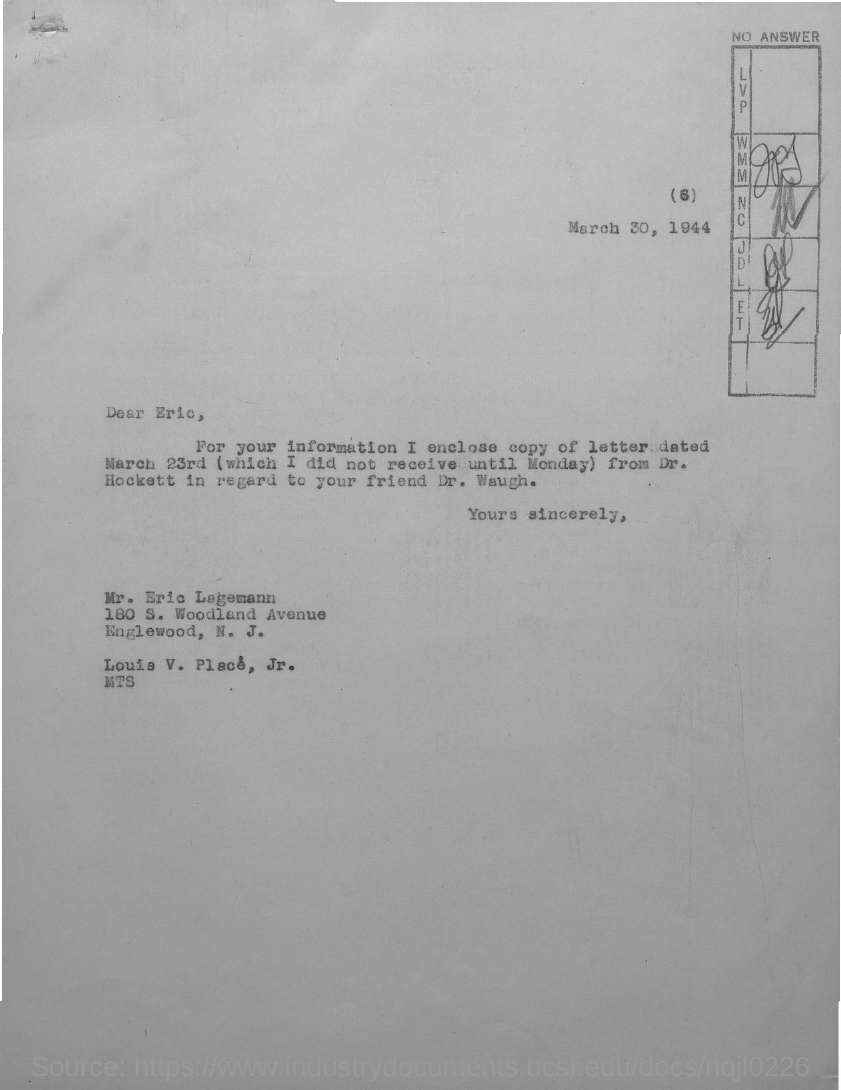Give some essential details in this illustration. The letter is addressed to Eric Legemann. 